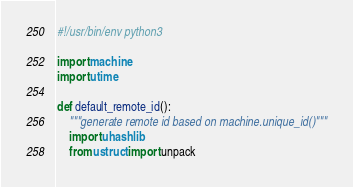Convert code to text. <code><loc_0><loc_0><loc_500><loc_500><_Python_>#!/usr/bin/env python3

import machine
import utime

def default_remote_id():
    """generate remote id based on machine.unique_id()"""
    import uhashlib
    from ustruct import unpack</code> 